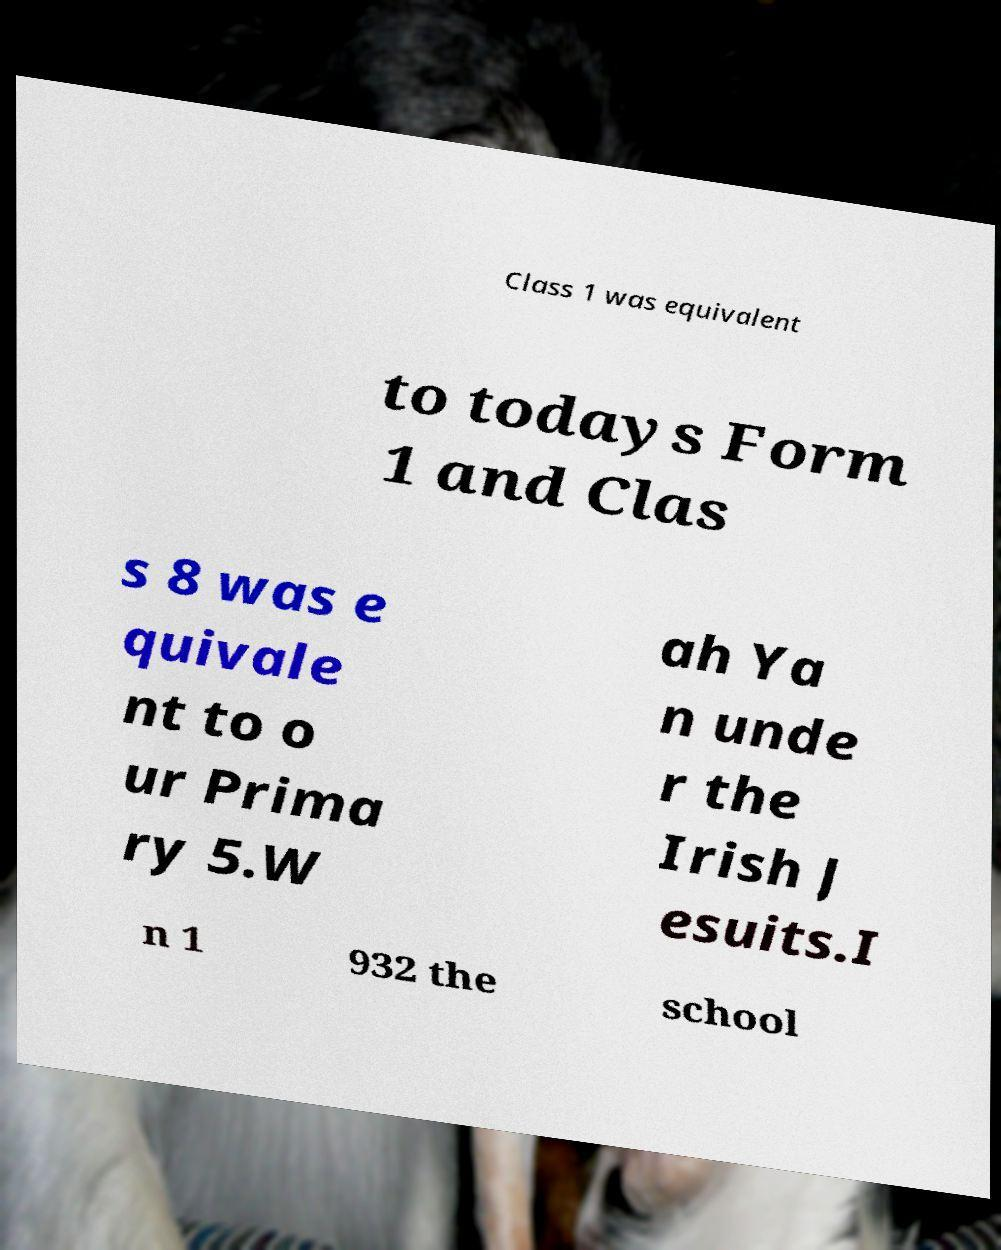For documentation purposes, I need the text within this image transcribed. Could you provide that? Class 1 was equivalent to todays Form 1 and Clas s 8 was e quivale nt to o ur Prima ry 5.W ah Ya n unde r the Irish J esuits.I n 1 932 the school 